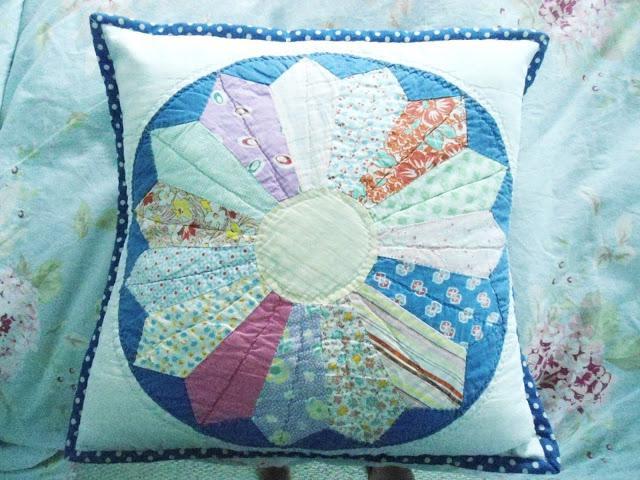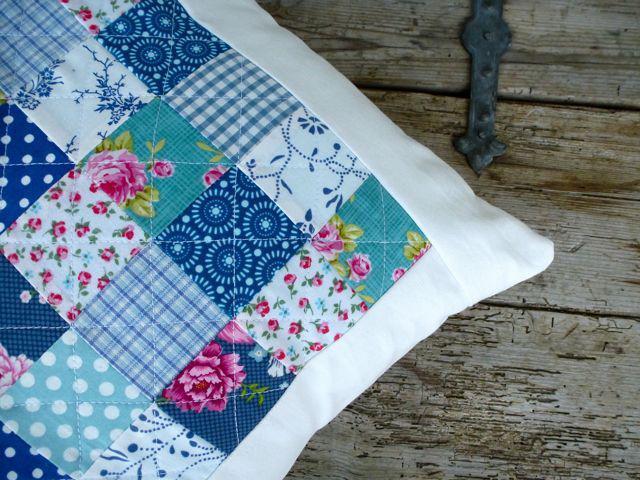The first image is the image on the left, the second image is the image on the right. Examine the images to the left and right. Is the description "There is at least two pillows in the right image." accurate? Answer yes or no. No. The first image is the image on the left, the second image is the image on the right. Assess this claim about the two images: "There are flowers on at least one pillow in each image, and none of the pillow are fuzzy.". Correct or not? Answer yes or no. Yes. 